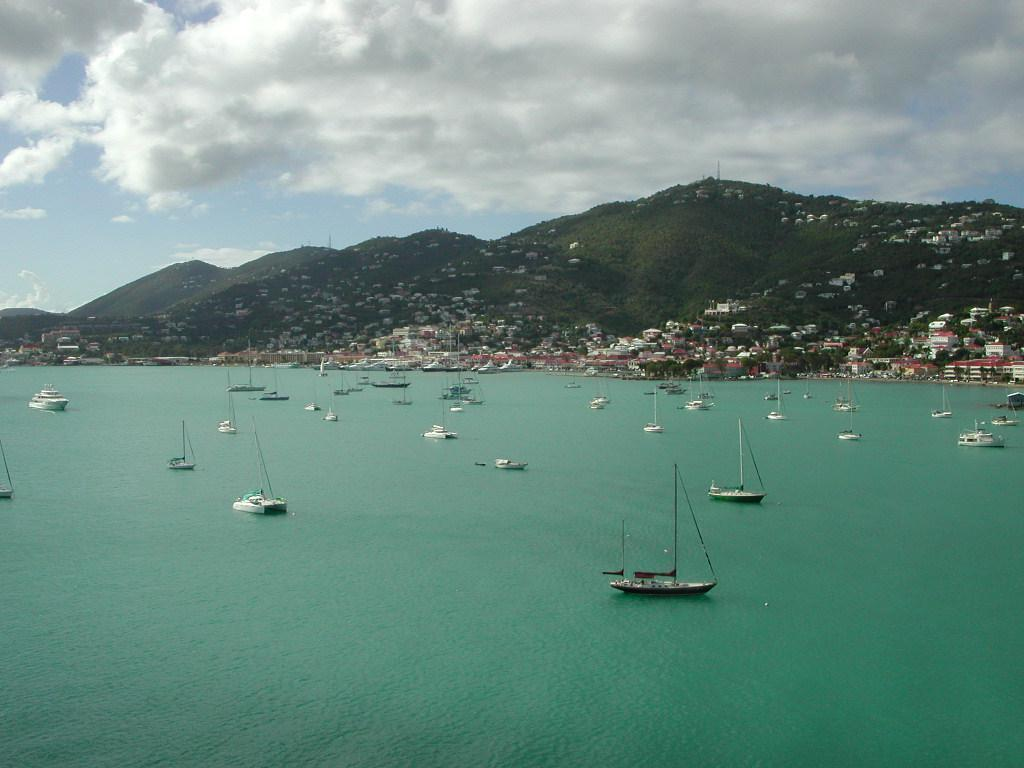What is the main subject of the image? The main subject of the image is boats. Where are the boats located? The boats are on the water in the center of the image. What can be seen in the background of the image? There are houses and trees in the background of the image. How many ladybugs are sitting on the boats in the image? There are no ladybugs present in the image; it features boats on the water with houses and trees in the background. 